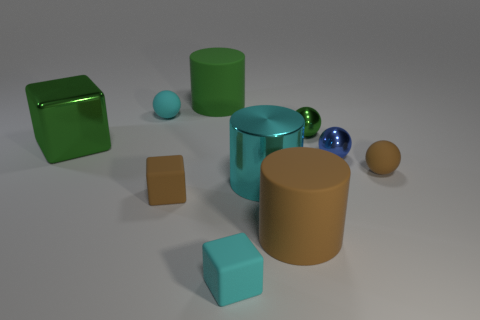What number of metal things are there? The image showcases a collection of objects, some with a metallic sheen suggestive of metal. However, without knowing the actual materials used, it cannot be definitively stated how many objects are made of metal, if any. Reflective surfaces and color alone are not reliable indicators of composition. 